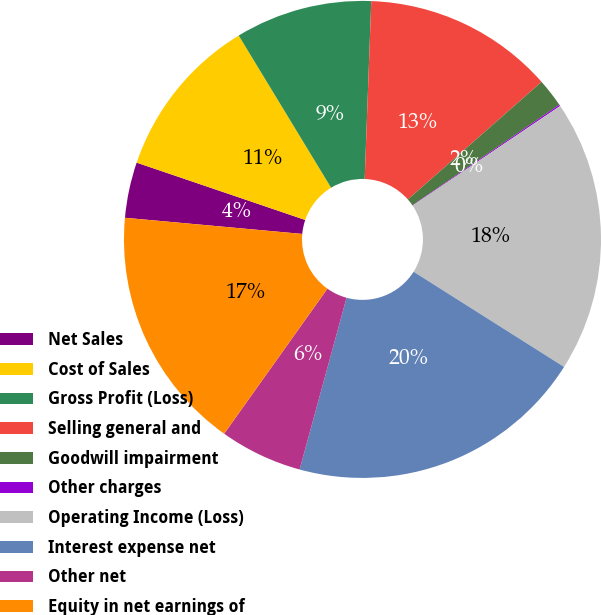Convert chart to OTSL. <chart><loc_0><loc_0><loc_500><loc_500><pie_chart><fcel>Net Sales<fcel>Cost of Sales<fcel>Gross Profit (Loss)<fcel>Selling general and<fcel>Goodwill impairment<fcel>Other charges<fcel>Operating Income (Loss)<fcel>Interest expense net<fcel>Other net<fcel>Equity in net earnings of<nl><fcel>3.77%<fcel>11.1%<fcel>9.27%<fcel>12.93%<fcel>1.93%<fcel>0.1%<fcel>18.43%<fcel>20.27%<fcel>5.6%<fcel>16.6%<nl></chart> 